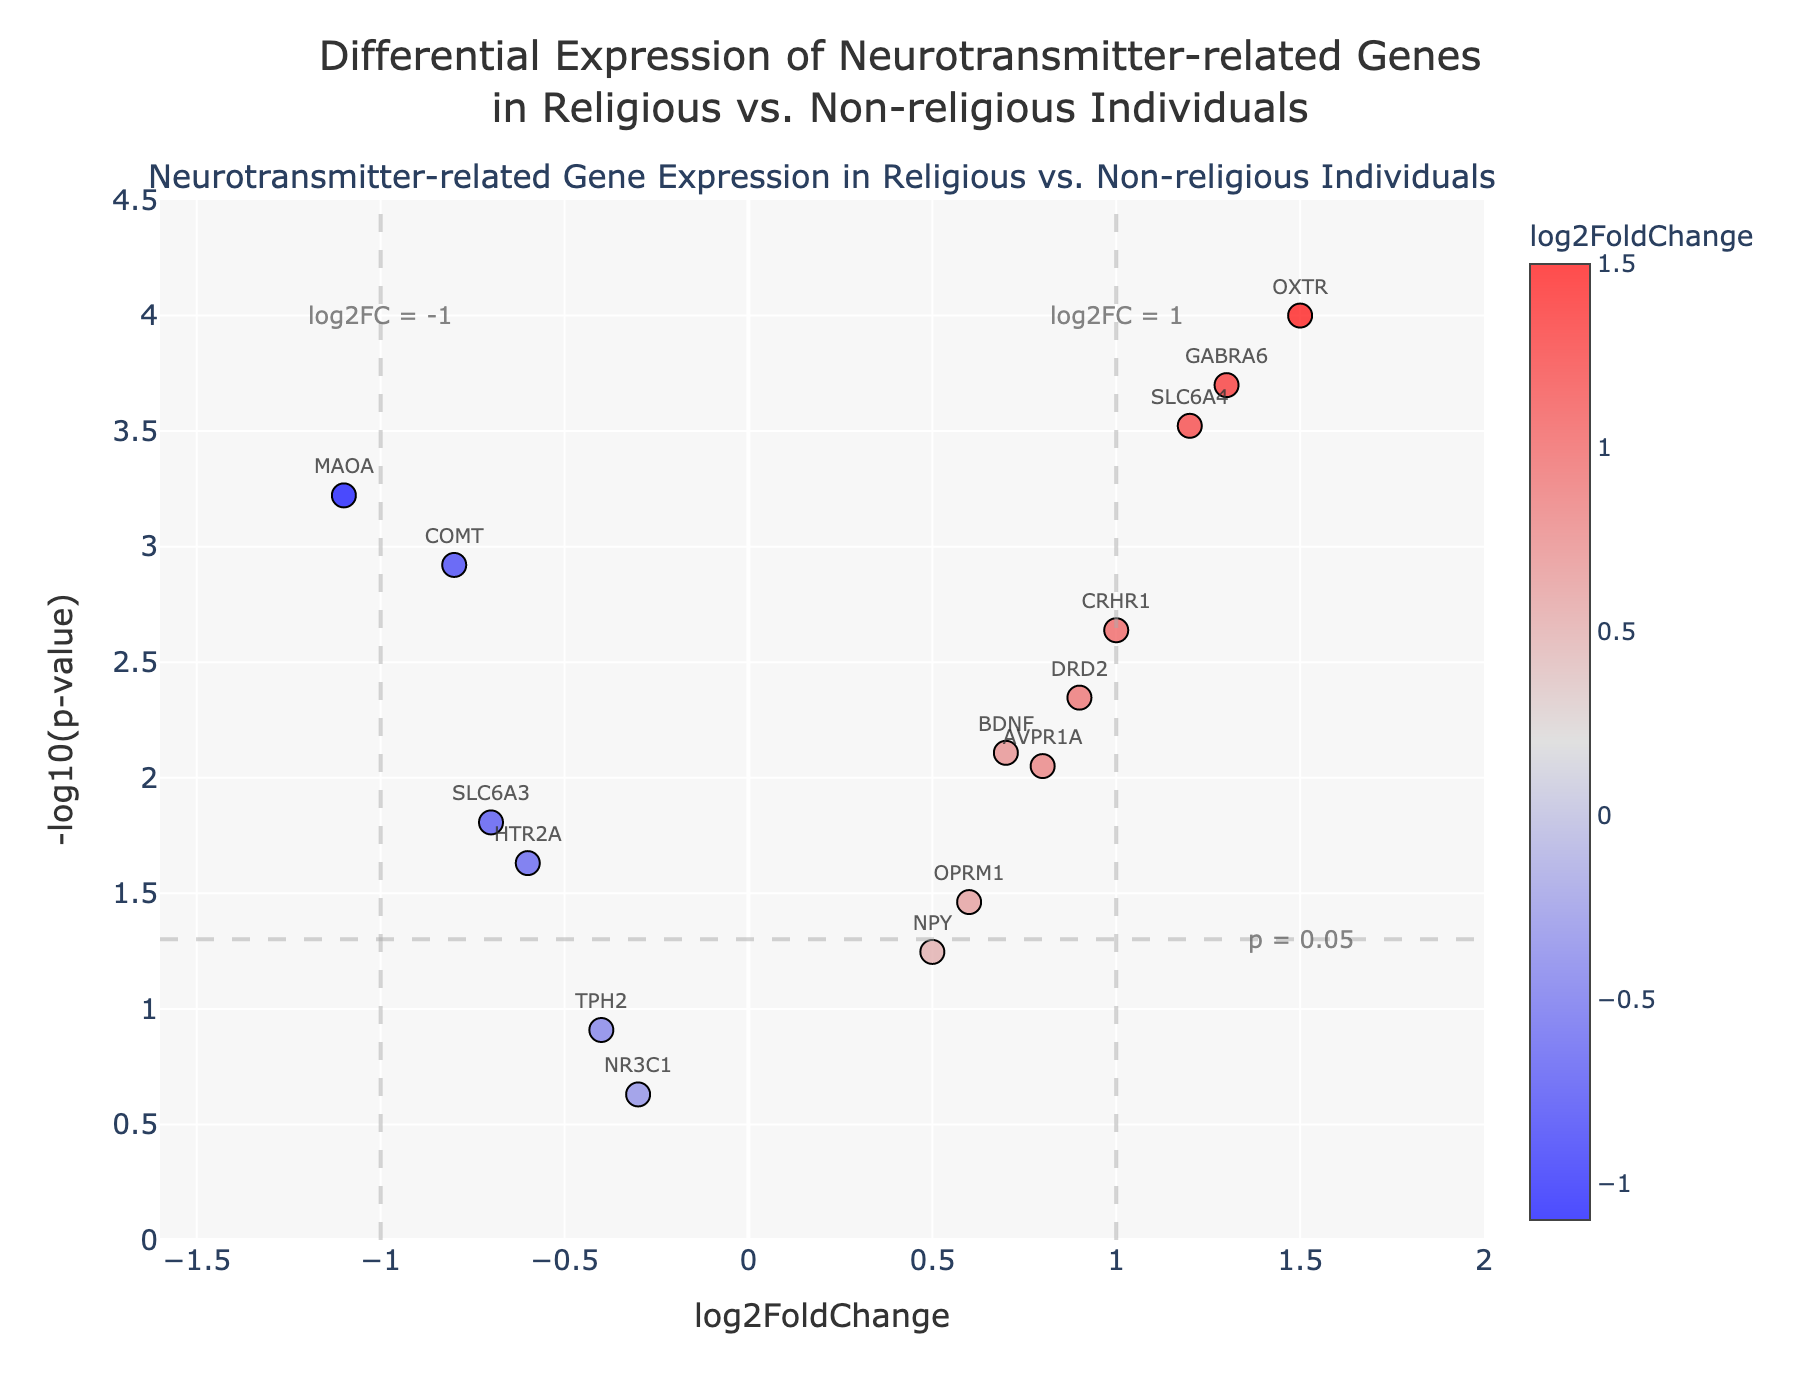What is the title of the plot? The title of the plot is displayed at the top and reads, "Differential Expression of Neurotransmitter-related Genes in Religious vs. Non-religious Individuals".
Answer: Differential Expression of Neurotransmitter-related Genes in Religious vs. Non-religious Individuals How many genes have a p-value less than 0.05? In the plot, genes with p-values less than 0.05 appear above the horizontal dashed line, which is the threshold for p = 0.05. Counting the genes above this line, we determine there are 13 such genes.
Answer: 13 What color represents the highest log2FoldChange values? The highest log2FoldChange values are represented by the red color as indicated by the color scale on the right side of the plot.
Answer: Red Which gene shows the highest -log10(p-value)? Observing the y-axis and identifying the data point at the highest vertical position, we see that OXTR has the highest -log10(pvalue) value.
Answer: OXTR What is the log2FoldChange and p-value for the COMT gene? We first locate the COMT gene in the plot. The hover text associated with this point indicates the log2FoldChange is -0.8 and the p-value is 0.0012.
Answer: log2FoldChange: -0.8, p-value: 0.0012 Which gene has a log2FoldChange value of around 1.2? By inspecting the plot along the x-axis near the 1.2 mark, we identify the gene labeled SLC6A4 at that position.
Answer: SLC6A4 Describe the overall trend of the genes with higher positive log2FoldChange values. Genes with higher positive log2FoldChange values (greater than 1) such as OXTR and GABRA6 are present. These genes are distinguished by their significant p-values (low p-values represented by the high -log10(p-value) values).
Answer: Higher log2FoldChange genes (above 1) are significant (low p-values) Which gene near the horizontal line has a log2FoldChange of about 0.5? Checking near the horizontal line (representing a -log10(p-value) around 1.3, the threshold for p = 0.05), we find the gene NPY which has a log2FoldChange close to 0.5.
Answer: NPY Are there more upregulated (positive log2FoldChange) or downregulated (negative log2FoldChange) genes with significant p-values (below 0.05)? We count the number of genes on either side of the y-axis with p-values below 0.05. There are 7 upregulated genes (positive log2FoldChange) and 6 downregulated genes (negative log2FoldChange).
Answer: More upregulated genes (7 vs. 6) What is the vertical position on the y-axis indicating a p-value of 0.05? The plot shows a horizontal dashed line denoting p = 0.05, which corresponds to a -log10(p-value) of approximately 1.3.
Answer: 1.3 